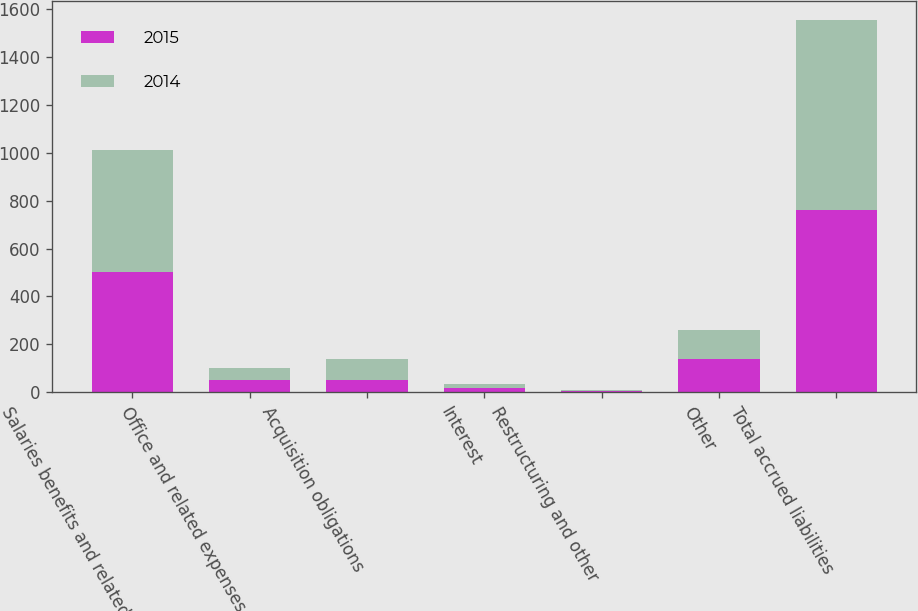<chart> <loc_0><loc_0><loc_500><loc_500><stacked_bar_chart><ecel><fcel>Salaries benefits and related<fcel>Office and related expenses<fcel>Acquisition obligations<fcel>Interest<fcel>Restructuring and other<fcel>Other<fcel>Total accrued liabilities<nl><fcel>2015<fcel>502.4<fcel>51<fcel>50.1<fcel>17.3<fcel>3.3<fcel>136.2<fcel>760.3<nl><fcel>2014<fcel>510.6<fcel>51.5<fcel>88.1<fcel>18.3<fcel>5.5<fcel>122<fcel>796<nl></chart> 